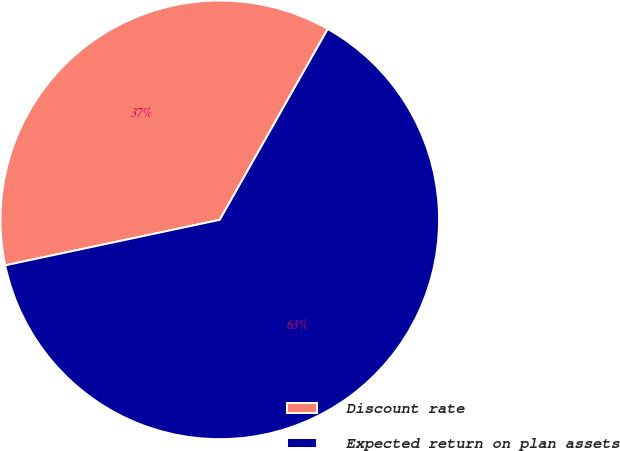Convert chart to OTSL. <chart><loc_0><loc_0><loc_500><loc_500><pie_chart><fcel>Discount rate<fcel>Expected return on plan assets<nl><fcel>36.52%<fcel>63.48%<nl></chart> 